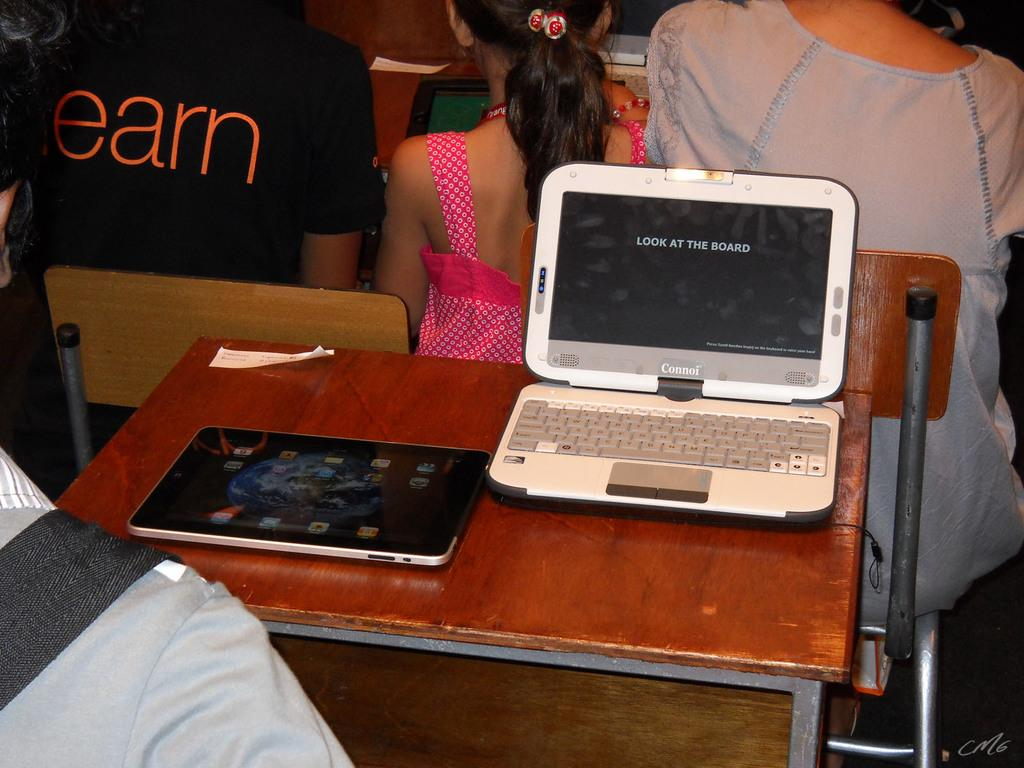What piece of furniture is present in the image? There is a table in the image. What electronic devices are on the table? There is a laptop and an iPad on the table. What are the people in the image doing? The people are sitting on chairs in the image. What type of insect can be seen crawling on the laptop in the image? There are no insects present in the image, and therefore no insect can be seen crawling on the laptop. 